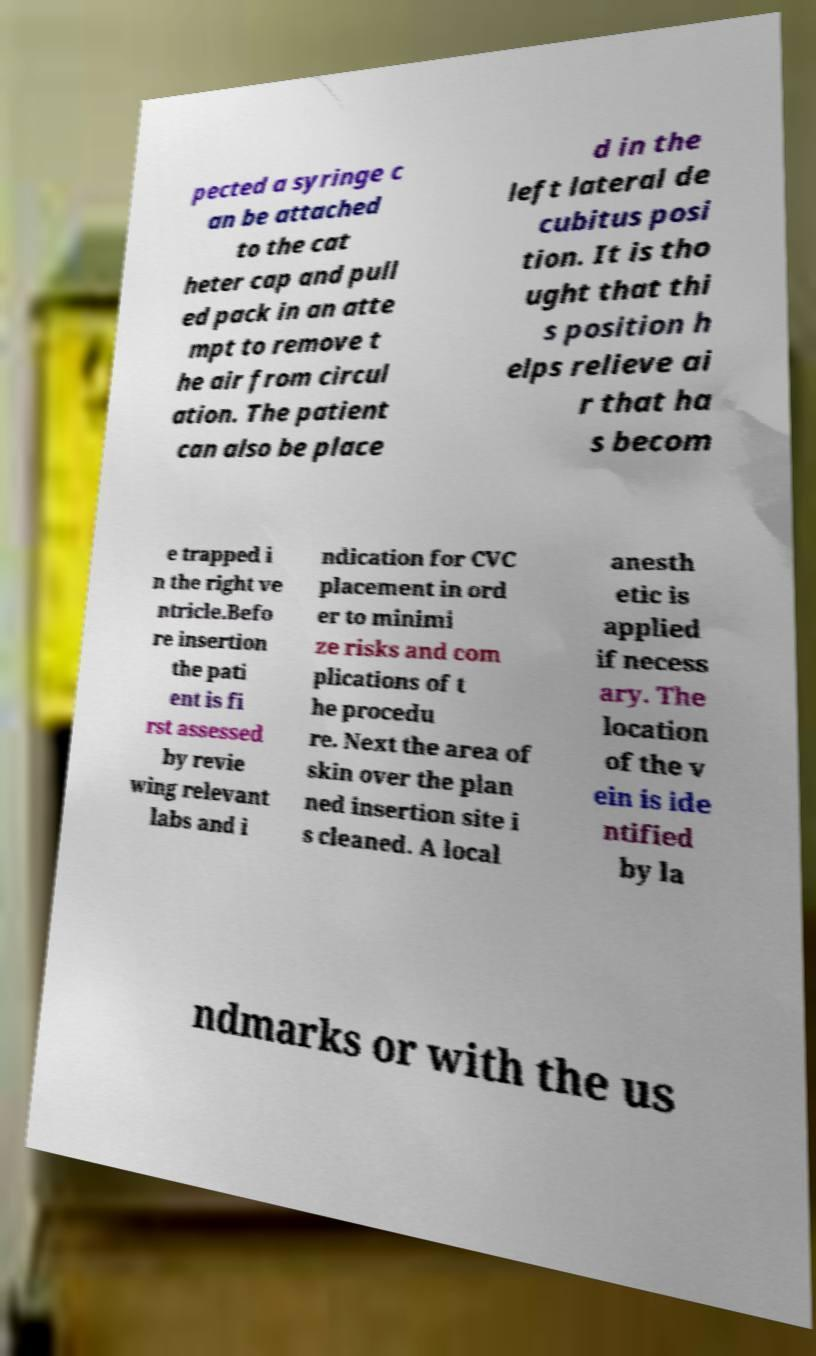For documentation purposes, I need the text within this image transcribed. Could you provide that? pected a syringe c an be attached to the cat heter cap and pull ed pack in an atte mpt to remove t he air from circul ation. The patient can also be place d in the left lateral de cubitus posi tion. It is tho ught that thi s position h elps relieve ai r that ha s becom e trapped i n the right ve ntricle.Befo re insertion the pati ent is fi rst assessed by revie wing relevant labs and i ndication for CVC placement in ord er to minimi ze risks and com plications of t he procedu re. Next the area of skin over the plan ned insertion site i s cleaned. A local anesth etic is applied if necess ary. The location of the v ein is ide ntified by la ndmarks or with the us 